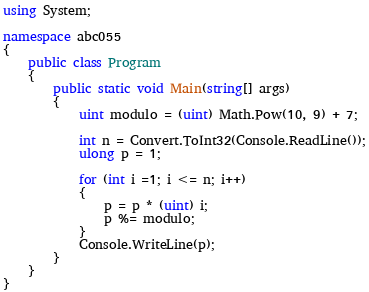Convert code to text. <code><loc_0><loc_0><loc_500><loc_500><_C#_>using System;

namespace abc055
{
    public class Program
    {
        public static void Main(string[] args)
        {
            uint modulo = (uint) Math.Pow(10, 9) + 7;
 
            int n = Convert.ToInt32(Console.ReadLine());
            ulong p = 1;

            for (int i =1; i <= n; i++)
            {
                p = p * (uint) i;
                p %= modulo;
            }
            Console.WriteLine(p);
        }
    }
}</code> 